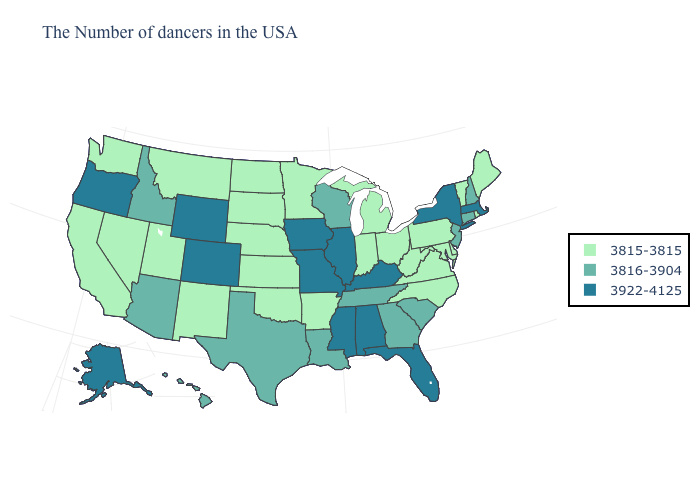How many symbols are there in the legend?
Concise answer only. 3. Is the legend a continuous bar?
Be succinct. No. Name the states that have a value in the range 3816-3904?
Be succinct. New Hampshire, Connecticut, New Jersey, South Carolina, Georgia, Tennessee, Wisconsin, Louisiana, Texas, Arizona, Idaho, Hawaii. Does Mississippi have the lowest value in the USA?
Be succinct. No. What is the value of Missouri?
Short answer required. 3922-4125. Which states hav the highest value in the Northeast?
Write a very short answer. Massachusetts, New York. What is the highest value in the South ?
Give a very brief answer. 3922-4125. What is the value of Vermont?
Keep it brief. 3815-3815. What is the highest value in the USA?
Keep it brief. 3922-4125. What is the lowest value in states that border North Carolina?
Keep it brief. 3815-3815. Name the states that have a value in the range 3815-3815?
Write a very short answer. Maine, Rhode Island, Vermont, Delaware, Maryland, Pennsylvania, Virginia, North Carolina, West Virginia, Ohio, Michigan, Indiana, Arkansas, Minnesota, Kansas, Nebraska, Oklahoma, South Dakota, North Dakota, New Mexico, Utah, Montana, Nevada, California, Washington. What is the value of Arizona?
Be succinct. 3816-3904. What is the lowest value in the USA?
Concise answer only. 3815-3815. Is the legend a continuous bar?
Give a very brief answer. No. What is the value of Maine?
Answer briefly. 3815-3815. 